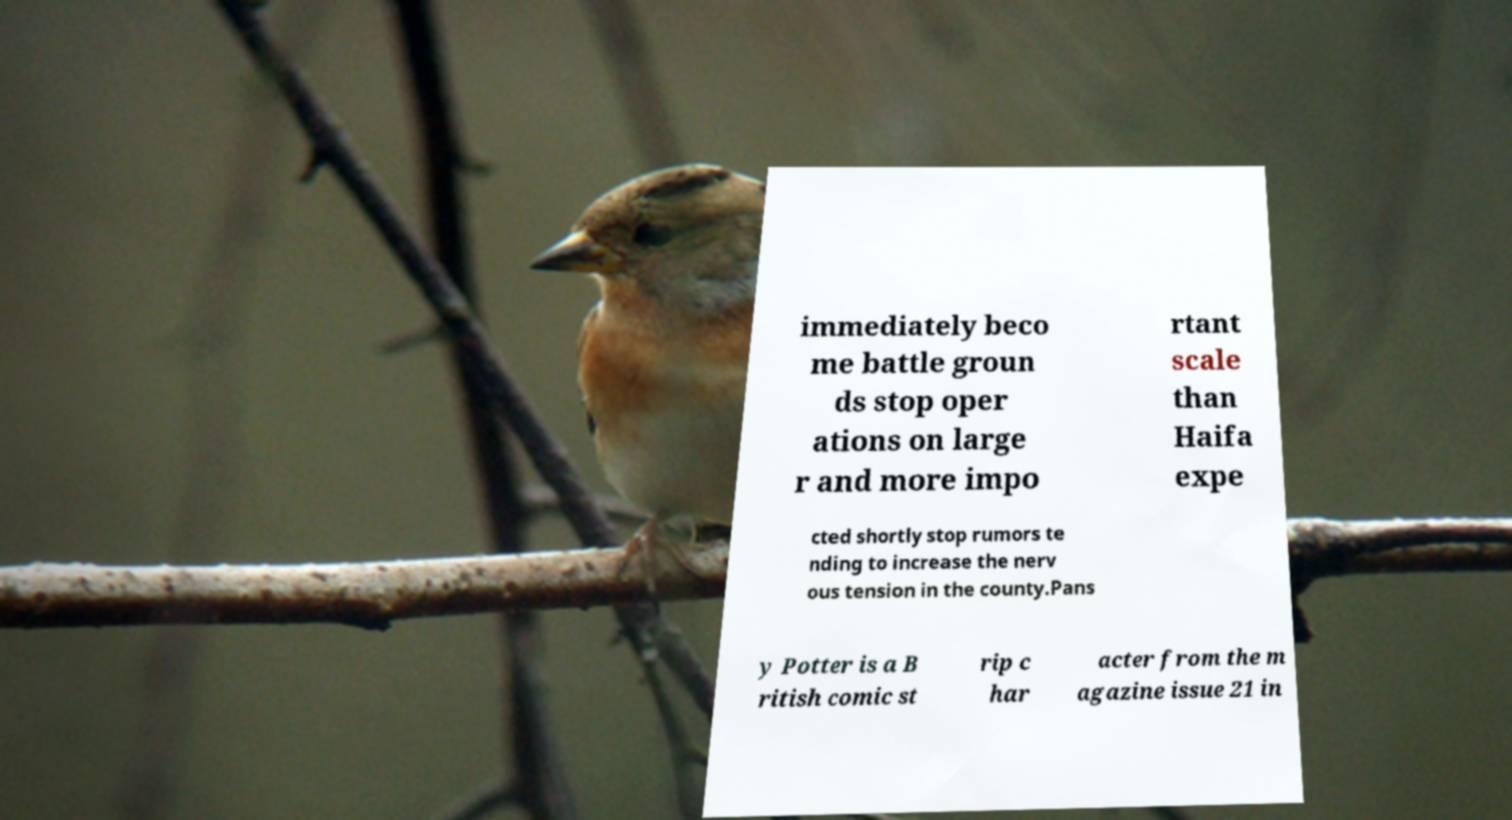Can you read and provide the text displayed in the image?This photo seems to have some interesting text. Can you extract and type it out for me? immediately beco me battle groun ds stop oper ations on large r and more impo rtant scale than Haifa expe cted shortly stop rumors te nding to increase the nerv ous tension in the county.Pans y Potter is a B ritish comic st rip c har acter from the m agazine issue 21 in 